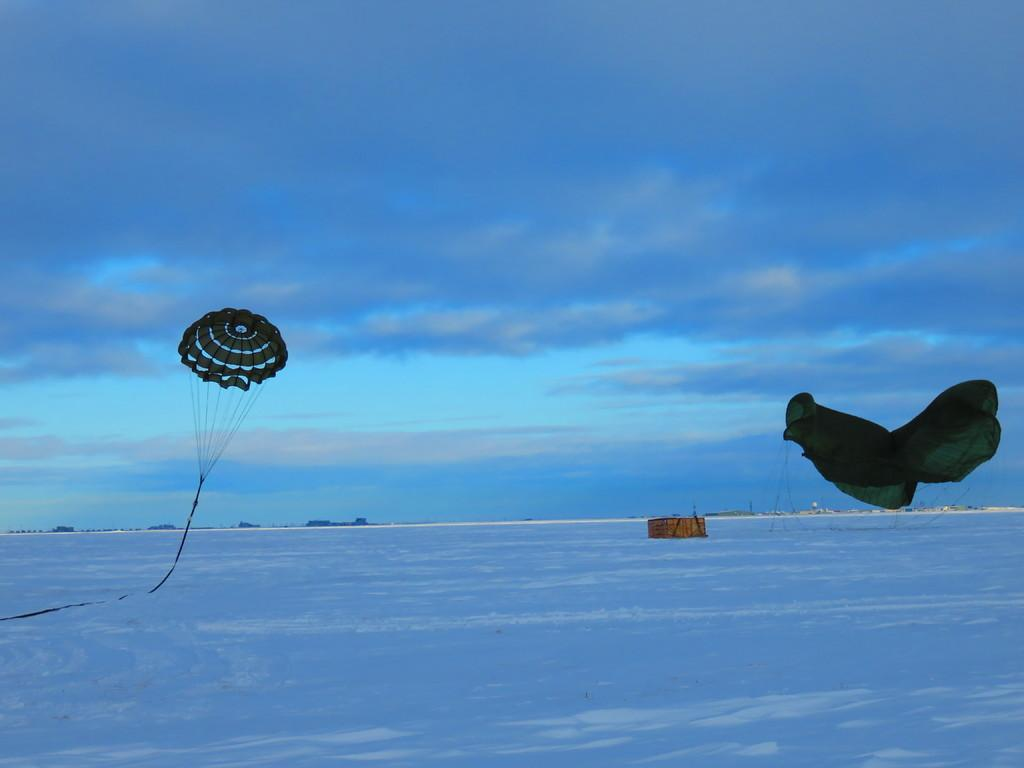What is the weather like in the image? There is snow in the image, indicating a cold and likely wintry weather. What can be seen in the sky in the image? There are clouds in the sky in the image. What are the parachutes associated with in the image? The presence of parachutes suggests that there may be people or objects descending from a higher altitude. What does the snow smell like in the image? Snow does not have a smell, so it is not possible to determine what it might smell like in the image. 